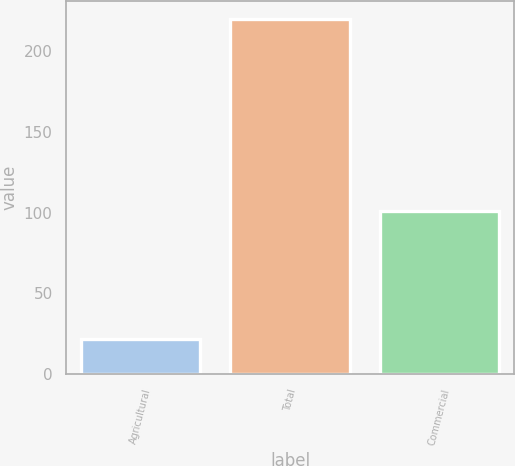Convert chart to OTSL. <chart><loc_0><loc_0><loc_500><loc_500><bar_chart><fcel>Agricultural<fcel>Total<fcel>Commercial<nl><fcel>22<fcel>220<fcel>101<nl></chart> 